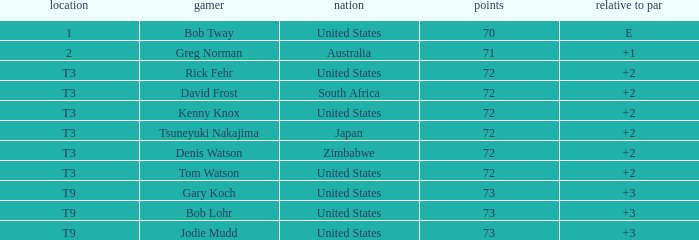What is the top score for tsuneyuki nakajima? 72.0. 